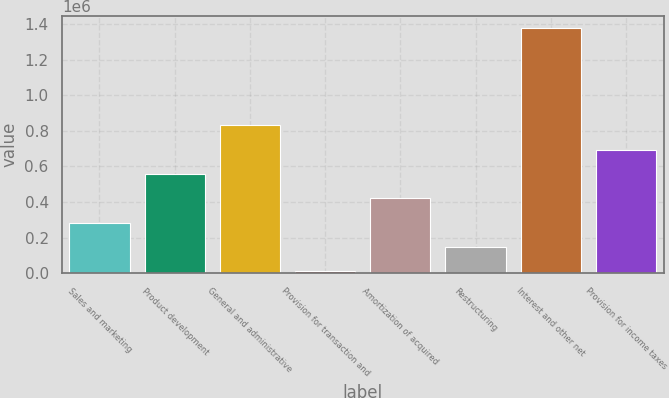Convert chart. <chart><loc_0><loc_0><loc_500><loc_500><bar_chart><fcel>Sales and marketing<fcel>Product development<fcel>General and administrative<fcel>Provision for transaction and<fcel>Amortization of acquired<fcel>Restructuring<fcel>Interest and other net<fcel>Provision for income taxes<nl><fcel>283034<fcel>556653<fcel>830271<fcel>9415<fcel>419843<fcel>146224<fcel>1.37751e+06<fcel>693462<nl></chart> 